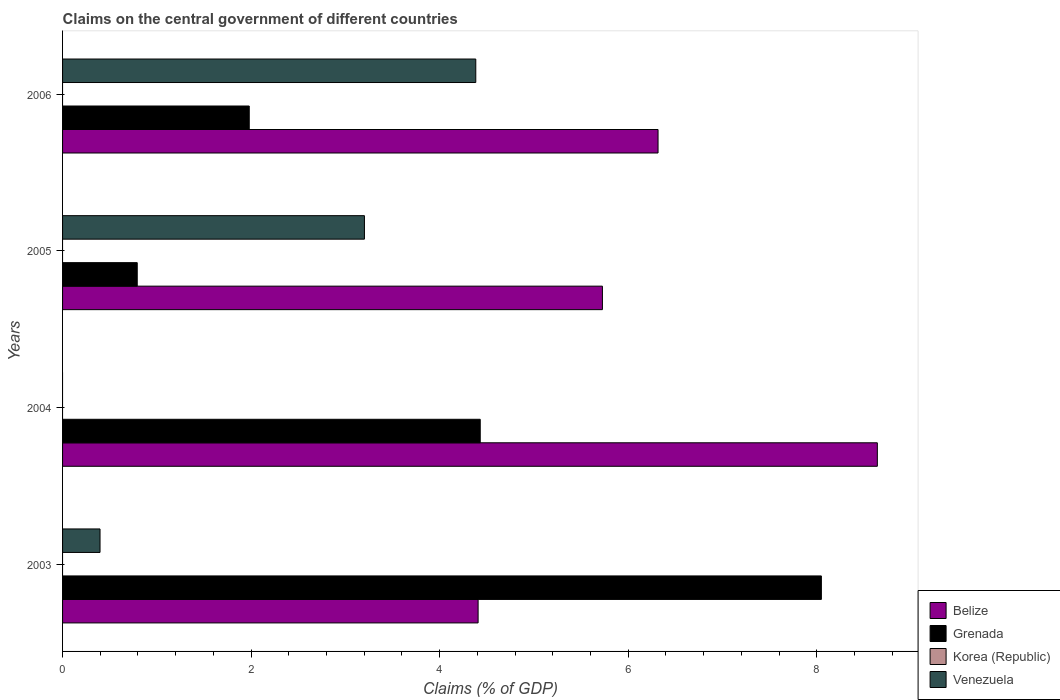Are the number of bars per tick equal to the number of legend labels?
Make the answer very short. No. Are the number of bars on each tick of the Y-axis equal?
Offer a very short reply. No. What is the percentage of GDP claimed on the central government in Grenada in 2006?
Ensure brevity in your answer.  1.98. Across all years, what is the maximum percentage of GDP claimed on the central government in Venezuela?
Provide a short and direct response. 4.38. Across all years, what is the minimum percentage of GDP claimed on the central government in Grenada?
Ensure brevity in your answer.  0.79. What is the total percentage of GDP claimed on the central government in Belize in the graph?
Provide a succinct answer. 25.09. What is the difference between the percentage of GDP claimed on the central government in Grenada in 2003 and that in 2005?
Keep it short and to the point. 7.26. What is the difference between the percentage of GDP claimed on the central government in Belize in 2004 and the percentage of GDP claimed on the central government in Grenada in 2005?
Your answer should be very brief. 7.85. What is the average percentage of GDP claimed on the central government in Venezuela per year?
Your response must be concise. 2. In the year 2004, what is the difference between the percentage of GDP claimed on the central government in Grenada and percentage of GDP claimed on the central government in Belize?
Your response must be concise. -4.21. In how many years, is the percentage of GDP claimed on the central government in Grenada greater than 7.2 %?
Provide a succinct answer. 1. What is the ratio of the percentage of GDP claimed on the central government in Venezuela in 2003 to that in 2005?
Make the answer very short. 0.12. Is the percentage of GDP claimed on the central government in Venezuela in 2003 less than that in 2006?
Give a very brief answer. Yes. Is the difference between the percentage of GDP claimed on the central government in Grenada in 2003 and 2004 greater than the difference between the percentage of GDP claimed on the central government in Belize in 2003 and 2004?
Provide a short and direct response. Yes. What is the difference between the highest and the second highest percentage of GDP claimed on the central government in Belize?
Your answer should be very brief. 2.33. What is the difference between the highest and the lowest percentage of GDP claimed on the central government in Venezuela?
Your answer should be very brief. 4.38. Is it the case that in every year, the sum of the percentage of GDP claimed on the central government in Venezuela and percentage of GDP claimed on the central government in Korea (Republic) is greater than the percentage of GDP claimed on the central government in Belize?
Your answer should be very brief. No. Are all the bars in the graph horizontal?
Offer a very short reply. Yes. How many years are there in the graph?
Your answer should be compact. 4. Does the graph contain any zero values?
Ensure brevity in your answer.  Yes. Does the graph contain grids?
Ensure brevity in your answer.  No. Where does the legend appear in the graph?
Your response must be concise. Bottom right. How many legend labels are there?
Your answer should be very brief. 4. What is the title of the graph?
Give a very brief answer. Claims on the central government of different countries. Does "Heavily indebted poor countries" appear as one of the legend labels in the graph?
Your response must be concise. No. What is the label or title of the X-axis?
Provide a short and direct response. Claims (% of GDP). What is the label or title of the Y-axis?
Give a very brief answer. Years. What is the Claims (% of GDP) of Belize in 2003?
Give a very brief answer. 4.41. What is the Claims (% of GDP) in Grenada in 2003?
Your answer should be very brief. 8.05. What is the Claims (% of GDP) in Korea (Republic) in 2003?
Make the answer very short. 0. What is the Claims (% of GDP) in Venezuela in 2003?
Ensure brevity in your answer.  0.4. What is the Claims (% of GDP) in Belize in 2004?
Ensure brevity in your answer.  8.64. What is the Claims (% of GDP) in Grenada in 2004?
Your answer should be compact. 4.43. What is the Claims (% of GDP) in Korea (Republic) in 2004?
Your response must be concise. 0. What is the Claims (% of GDP) in Belize in 2005?
Provide a short and direct response. 5.73. What is the Claims (% of GDP) of Grenada in 2005?
Offer a terse response. 0.79. What is the Claims (% of GDP) of Korea (Republic) in 2005?
Your answer should be compact. 0. What is the Claims (% of GDP) of Venezuela in 2005?
Your answer should be very brief. 3.2. What is the Claims (% of GDP) in Belize in 2006?
Ensure brevity in your answer.  6.32. What is the Claims (% of GDP) of Grenada in 2006?
Offer a terse response. 1.98. What is the Claims (% of GDP) in Venezuela in 2006?
Provide a short and direct response. 4.38. Across all years, what is the maximum Claims (% of GDP) in Belize?
Provide a short and direct response. 8.64. Across all years, what is the maximum Claims (% of GDP) of Grenada?
Offer a terse response. 8.05. Across all years, what is the maximum Claims (% of GDP) in Venezuela?
Your answer should be compact. 4.38. Across all years, what is the minimum Claims (% of GDP) in Belize?
Your response must be concise. 4.41. Across all years, what is the minimum Claims (% of GDP) of Grenada?
Make the answer very short. 0.79. What is the total Claims (% of GDP) in Belize in the graph?
Keep it short and to the point. 25.09. What is the total Claims (% of GDP) in Grenada in the graph?
Your answer should be compact. 15.25. What is the total Claims (% of GDP) of Venezuela in the graph?
Offer a very short reply. 7.98. What is the difference between the Claims (% of GDP) of Belize in 2003 and that in 2004?
Provide a short and direct response. -4.24. What is the difference between the Claims (% of GDP) of Grenada in 2003 and that in 2004?
Your answer should be compact. 3.62. What is the difference between the Claims (% of GDP) of Belize in 2003 and that in 2005?
Keep it short and to the point. -1.32. What is the difference between the Claims (% of GDP) in Grenada in 2003 and that in 2005?
Give a very brief answer. 7.26. What is the difference between the Claims (% of GDP) of Venezuela in 2003 and that in 2005?
Keep it short and to the point. -2.8. What is the difference between the Claims (% of GDP) of Belize in 2003 and that in 2006?
Your answer should be compact. -1.91. What is the difference between the Claims (% of GDP) in Grenada in 2003 and that in 2006?
Your answer should be very brief. 6.07. What is the difference between the Claims (% of GDP) in Venezuela in 2003 and that in 2006?
Make the answer very short. -3.99. What is the difference between the Claims (% of GDP) in Belize in 2004 and that in 2005?
Provide a succinct answer. 2.92. What is the difference between the Claims (% of GDP) in Grenada in 2004 and that in 2005?
Your response must be concise. 3.64. What is the difference between the Claims (% of GDP) in Belize in 2004 and that in 2006?
Give a very brief answer. 2.33. What is the difference between the Claims (% of GDP) in Grenada in 2004 and that in 2006?
Give a very brief answer. 2.45. What is the difference between the Claims (% of GDP) of Belize in 2005 and that in 2006?
Offer a very short reply. -0.59. What is the difference between the Claims (% of GDP) in Grenada in 2005 and that in 2006?
Keep it short and to the point. -1.19. What is the difference between the Claims (% of GDP) in Venezuela in 2005 and that in 2006?
Your answer should be very brief. -1.18. What is the difference between the Claims (% of GDP) of Belize in 2003 and the Claims (% of GDP) of Grenada in 2004?
Offer a very short reply. -0.02. What is the difference between the Claims (% of GDP) in Belize in 2003 and the Claims (% of GDP) in Grenada in 2005?
Give a very brief answer. 3.62. What is the difference between the Claims (% of GDP) in Belize in 2003 and the Claims (% of GDP) in Venezuela in 2005?
Provide a succinct answer. 1.21. What is the difference between the Claims (% of GDP) in Grenada in 2003 and the Claims (% of GDP) in Venezuela in 2005?
Provide a short and direct response. 4.85. What is the difference between the Claims (% of GDP) of Belize in 2003 and the Claims (% of GDP) of Grenada in 2006?
Keep it short and to the point. 2.43. What is the difference between the Claims (% of GDP) of Belize in 2003 and the Claims (% of GDP) of Venezuela in 2006?
Provide a succinct answer. 0.02. What is the difference between the Claims (% of GDP) in Grenada in 2003 and the Claims (% of GDP) in Venezuela in 2006?
Give a very brief answer. 3.67. What is the difference between the Claims (% of GDP) in Belize in 2004 and the Claims (% of GDP) in Grenada in 2005?
Give a very brief answer. 7.85. What is the difference between the Claims (% of GDP) of Belize in 2004 and the Claims (% of GDP) of Venezuela in 2005?
Your answer should be compact. 5.44. What is the difference between the Claims (% of GDP) of Grenada in 2004 and the Claims (% of GDP) of Venezuela in 2005?
Your answer should be compact. 1.23. What is the difference between the Claims (% of GDP) of Belize in 2004 and the Claims (% of GDP) of Grenada in 2006?
Ensure brevity in your answer.  6.66. What is the difference between the Claims (% of GDP) in Belize in 2004 and the Claims (% of GDP) in Venezuela in 2006?
Provide a short and direct response. 4.26. What is the difference between the Claims (% of GDP) of Grenada in 2004 and the Claims (% of GDP) of Venezuela in 2006?
Your answer should be compact. 0.05. What is the difference between the Claims (% of GDP) in Belize in 2005 and the Claims (% of GDP) in Grenada in 2006?
Provide a short and direct response. 3.75. What is the difference between the Claims (% of GDP) in Belize in 2005 and the Claims (% of GDP) in Venezuela in 2006?
Give a very brief answer. 1.34. What is the difference between the Claims (% of GDP) of Grenada in 2005 and the Claims (% of GDP) of Venezuela in 2006?
Keep it short and to the point. -3.59. What is the average Claims (% of GDP) in Belize per year?
Your answer should be very brief. 6.27. What is the average Claims (% of GDP) of Grenada per year?
Your answer should be very brief. 3.81. What is the average Claims (% of GDP) in Venezuela per year?
Make the answer very short. 2. In the year 2003, what is the difference between the Claims (% of GDP) of Belize and Claims (% of GDP) of Grenada?
Ensure brevity in your answer.  -3.64. In the year 2003, what is the difference between the Claims (% of GDP) in Belize and Claims (% of GDP) in Venezuela?
Keep it short and to the point. 4.01. In the year 2003, what is the difference between the Claims (% of GDP) in Grenada and Claims (% of GDP) in Venezuela?
Offer a terse response. 7.65. In the year 2004, what is the difference between the Claims (% of GDP) of Belize and Claims (% of GDP) of Grenada?
Ensure brevity in your answer.  4.21. In the year 2005, what is the difference between the Claims (% of GDP) in Belize and Claims (% of GDP) in Grenada?
Your answer should be compact. 4.93. In the year 2005, what is the difference between the Claims (% of GDP) in Belize and Claims (% of GDP) in Venezuela?
Provide a short and direct response. 2.52. In the year 2005, what is the difference between the Claims (% of GDP) of Grenada and Claims (% of GDP) of Venezuela?
Make the answer very short. -2.41. In the year 2006, what is the difference between the Claims (% of GDP) in Belize and Claims (% of GDP) in Grenada?
Keep it short and to the point. 4.34. In the year 2006, what is the difference between the Claims (% of GDP) in Belize and Claims (% of GDP) in Venezuela?
Provide a succinct answer. 1.93. In the year 2006, what is the difference between the Claims (% of GDP) of Grenada and Claims (% of GDP) of Venezuela?
Offer a terse response. -2.4. What is the ratio of the Claims (% of GDP) of Belize in 2003 to that in 2004?
Keep it short and to the point. 0.51. What is the ratio of the Claims (% of GDP) of Grenada in 2003 to that in 2004?
Keep it short and to the point. 1.82. What is the ratio of the Claims (% of GDP) of Belize in 2003 to that in 2005?
Give a very brief answer. 0.77. What is the ratio of the Claims (% of GDP) in Grenada in 2003 to that in 2005?
Ensure brevity in your answer.  10.16. What is the ratio of the Claims (% of GDP) in Venezuela in 2003 to that in 2005?
Provide a short and direct response. 0.12. What is the ratio of the Claims (% of GDP) of Belize in 2003 to that in 2006?
Your answer should be compact. 0.7. What is the ratio of the Claims (% of GDP) in Grenada in 2003 to that in 2006?
Ensure brevity in your answer.  4.06. What is the ratio of the Claims (% of GDP) in Venezuela in 2003 to that in 2006?
Keep it short and to the point. 0.09. What is the ratio of the Claims (% of GDP) in Belize in 2004 to that in 2005?
Give a very brief answer. 1.51. What is the ratio of the Claims (% of GDP) in Grenada in 2004 to that in 2005?
Make the answer very short. 5.59. What is the ratio of the Claims (% of GDP) of Belize in 2004 to that in 2006?
Keep it short and to the point. 1.37. What is the ratio of the Claims (% of GDP) in Grenada in 2004 to that in 2006?
Your answer should be compact. 2.24. What is the ratio of the Claims (% of GDP) of Belize in 2005 to that in 2006?
Your answer should be very brief. 0.91. What is the ratio of the Claims (% of GDP) of Grenada in 2005 to that in 2006?
Keep it short and to the point. 0.4. What is the ratio of the Claims (% of GDP) of Venezuela in 2005 to that in 2006?
Keep it short and to the point. 0.73. What is the difference between the highest and the second highest Claims (% of GDP) in Belize?
Your response must be concise. 2.33. What is the difference between the highest and the second highest Claims (% of GDP) in Grenada?
Give a very brief answer. 3.62. What is the difference between the highest and the second highest Claims (% of GDP) in Venezuela?
Provide a short and direct response. 1.18. What is the difference between the highest and the lowest Claims (% of GDP) in Belize?
Offer a terse response. 4.24. What is the difference between the highest and the lowest Claims (% of GDP) of Grenada?
Offer a terse response. 7.26. What is the difference between the highest and the lowest Claims (% of GDP) of Venezuela?
Offer a terse response. 4.38. 